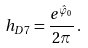Convert formula to latex. <formula><loc_0><loc_0><loc_500><loc_500>h _ { D 7 } = \frac { e ^ { \hat { \varphi } _ { 0 } } } { 2 \pi } \, .</formula> 